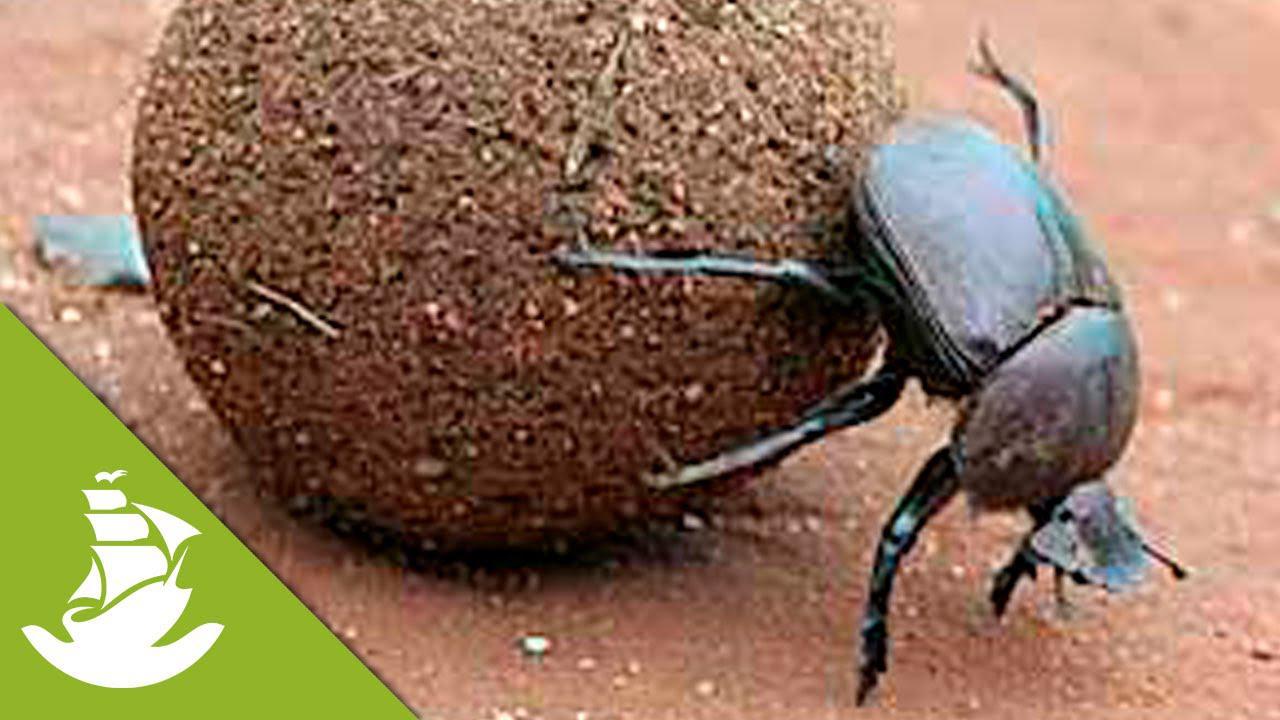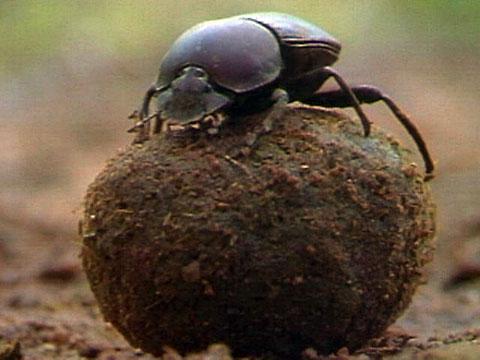The first image is the image on the left, the second image is the image on the right. Given the left and right images, does the statement "There are two beatles in total." hold true? Answer yes or no. Yes. The first image is the image on the left, the second image is the image on the right. For the images shown, is this caption "An image shows two beetles in proximity to a blue ball." true? Answer yes or no. No. The first image is the image on the left, the second image is the image on the right. Given the left and right images, does the statement "The insect in the image on the right is standing on top of the ball." hold true? Answer yes or no. Yes. The first image is the image on the left, the second image is the image on the right. For the images shown, is this caption "The ball in one of the images is not brown." true? Answer yes or no. No. 